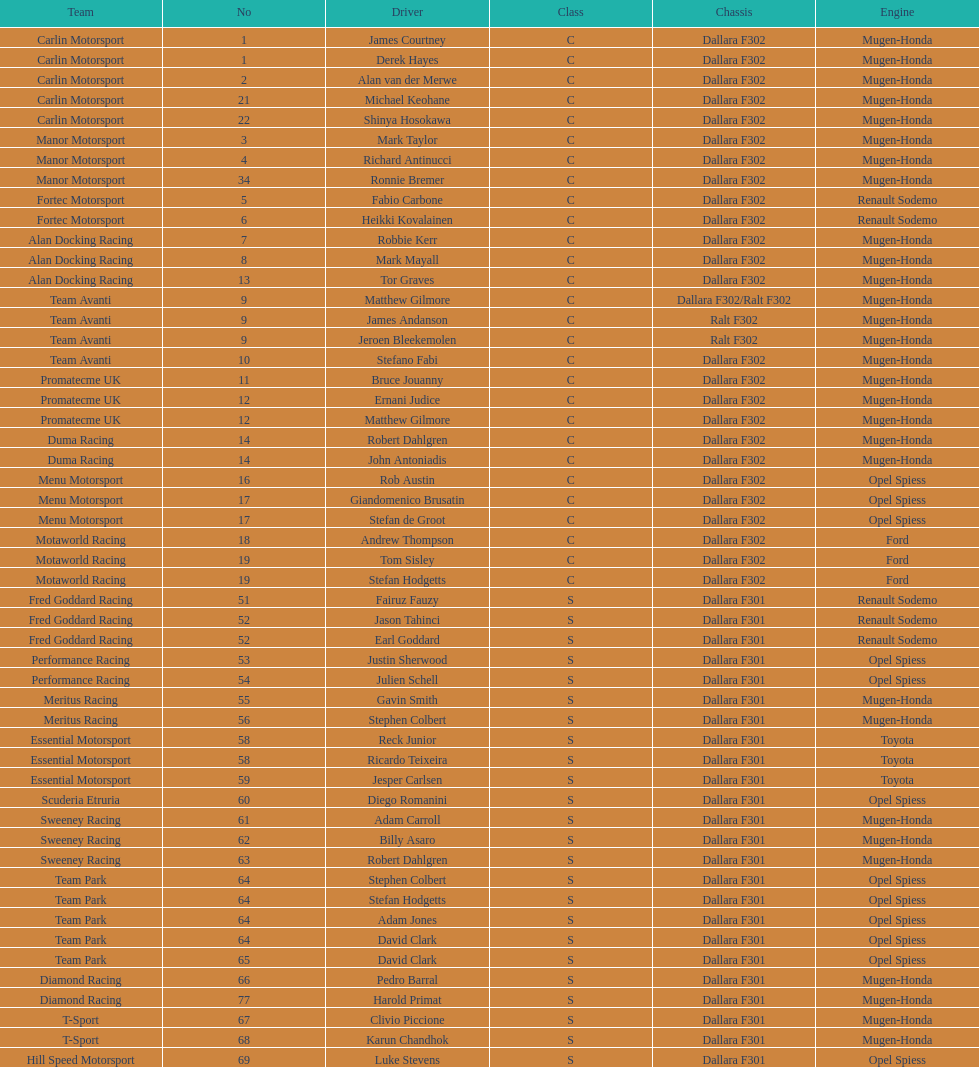How many class s (scholarship) teams are on the chart? 19. 